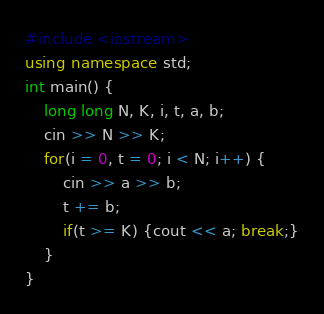<code> <loc_0><loc_0><loc_500><loc_500><_C++_>#include <iostream>
using namespace std;
int main() {
    long long N, K, i, t, a, b;
    cin >> N >> K;
    for(i = 0, t = 0; i < N; i++) {
        cin >> a >> b;
        t += b;
        if(t >= K) {cout << a; break;}
    }
}</code> 